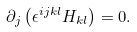Convert formula to latex. <formula><loc_0><loc_0><loc_500><loc_500>\partial _ { j } \left ( \epsilon ^ { i j k l } H _ { k l } \right ) = 0 .</formula> 